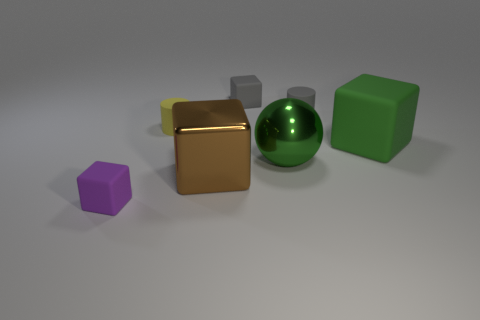There is a rubber cylinder on the right side of the small gray block; is it the same size as the cylinder that is left of the small gray rubber cylinder?
Provide a short and direct response. Yes. Is there a yellow cylinder that has the same material as the big brown cube?
Provide a short and direct response. No. What is the size of the shiny sphere that is the same color as the big rubber thing?
Provide a short and direct response. Large. There is a big cube that is to the left of the cube that is behind the yellow object; is there a cube that is left of it?
Provide a succinct answer. Yes. Are there any shiny balls left of the yellow matte cylinder?
Your answer should be compact. No. What number of big green metal spheres are on the right side of the rubber thing that is in front of the large green block?
Your response must be concise. 1. Do the yellow matte object and the green object that is behind the metallic ball have the same size?
Offer a very short reply. No. Is there a large metal cylinder that has the same color as the ball?
Give a very brief answer. No. What is the size of the gray cylinder that is the same material as the yellow cylinder?
Offer a terse response. Small. Is the material of the small yellow cylinder the same as the ball?
Make the answer very short. No. 